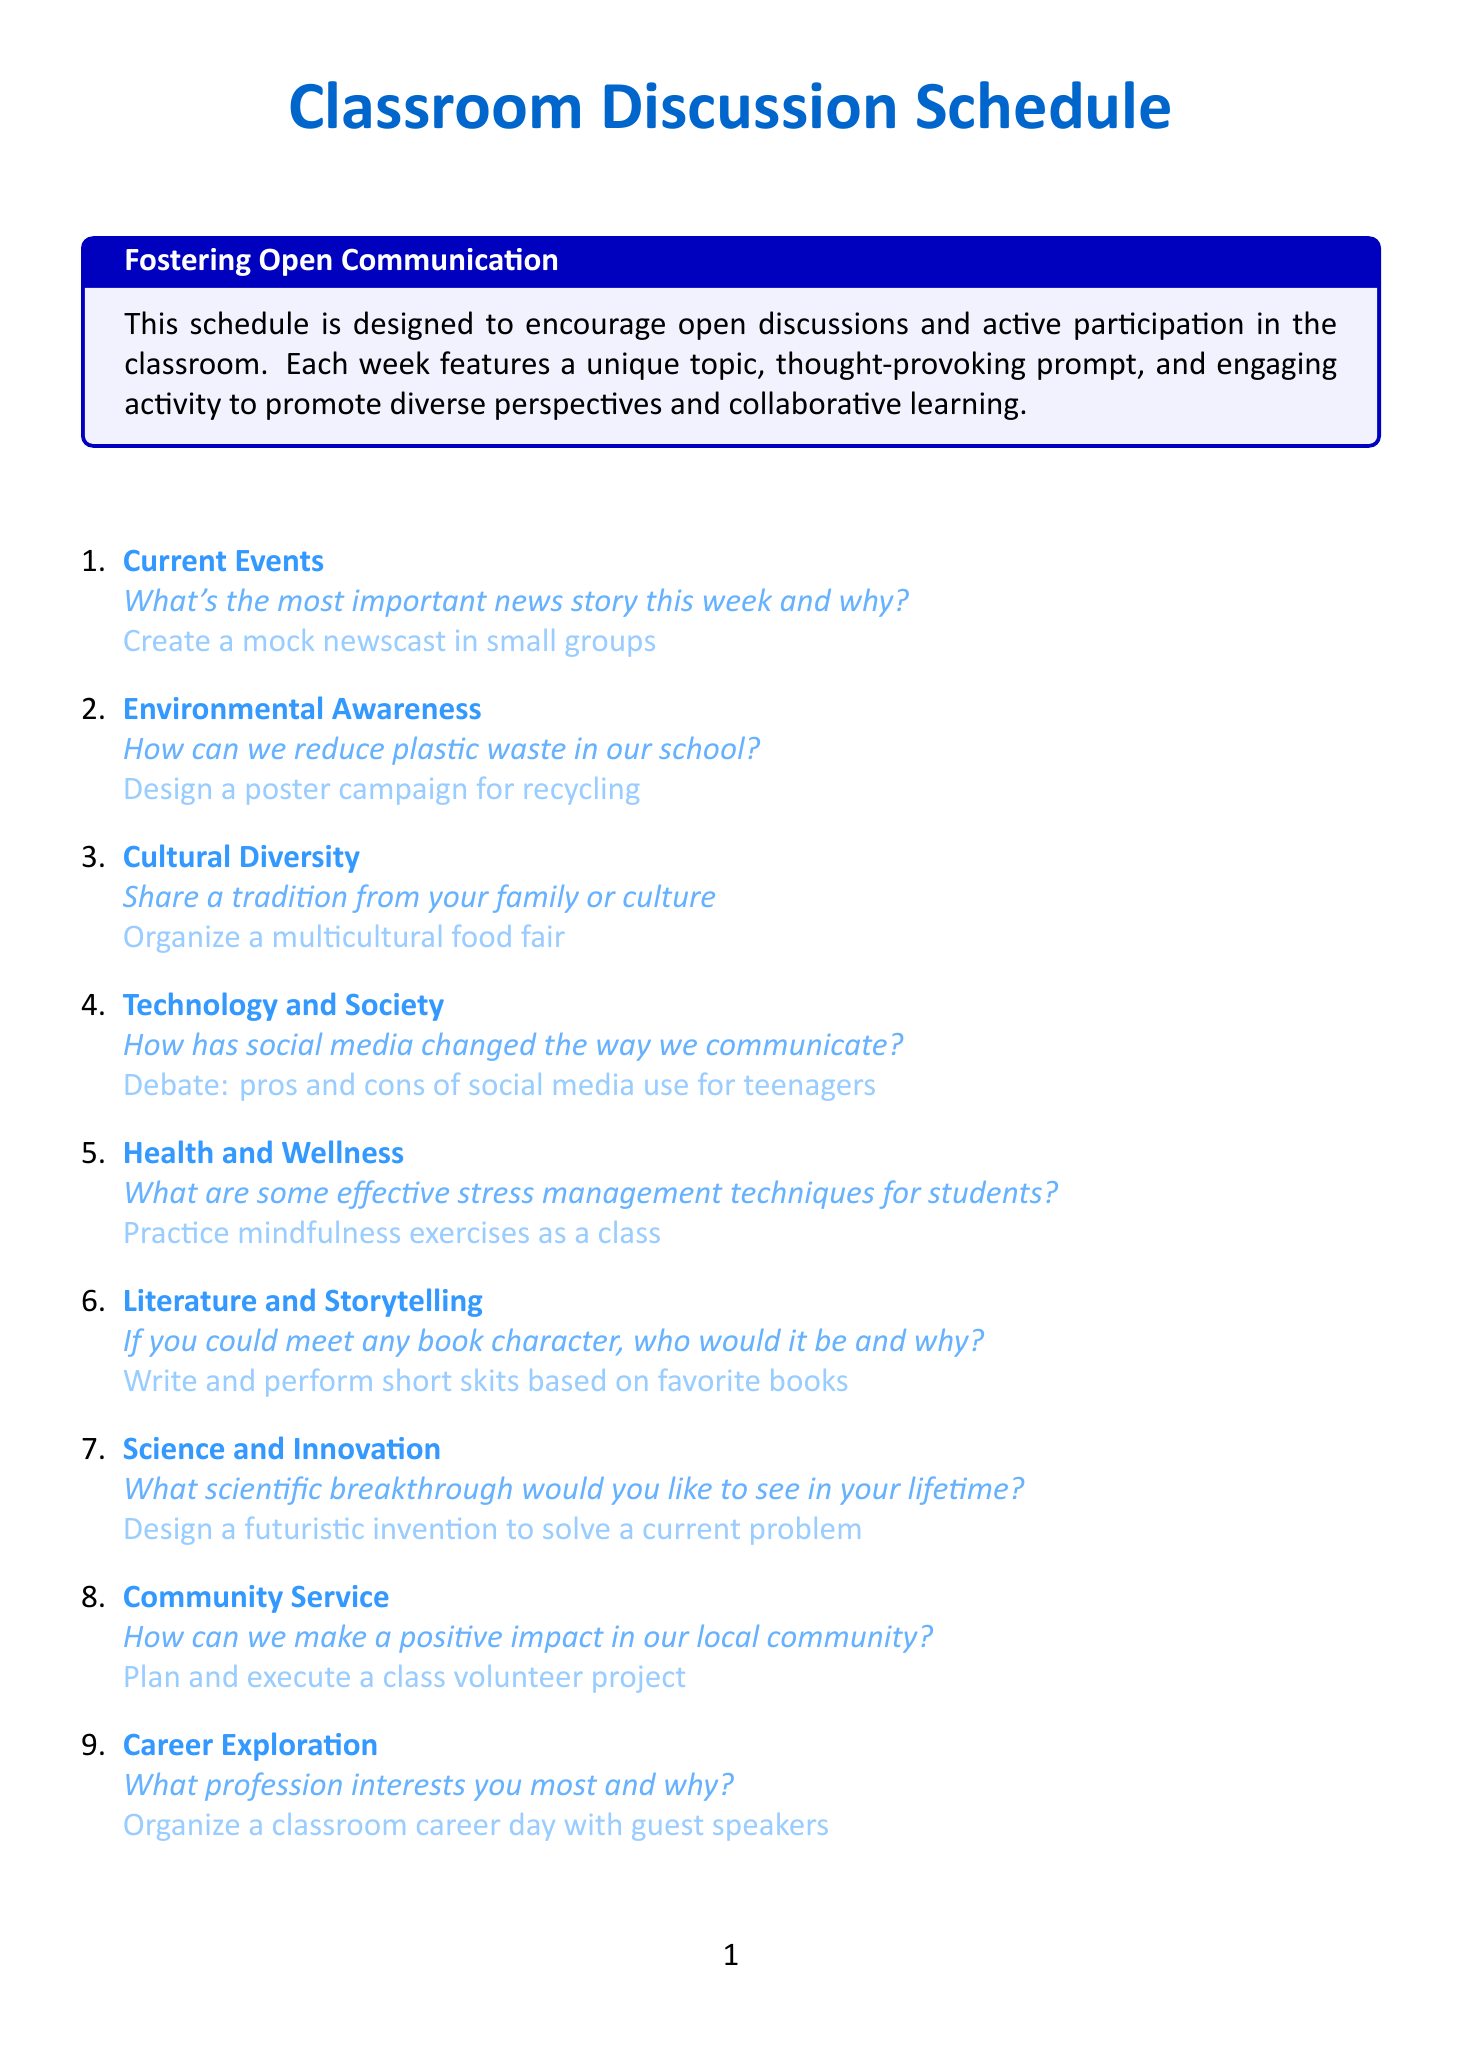What is the topic for week 3? The document lists the topic for week 3 as "Cultural Diversity."
Answer: Cultural Diversity What activity is suggested for week 5? The activity for week 5 is to "Practice mindfulness exercises as a class."
Answer: Practice mindfulness exercises as a class Which week focuses on Technology and Society? The document states that Technology and Society is the focus for week 4.
Answer: week 4 What prompt is given for the discussion in week 10? The prompt for week 10 asks, "How does art reflect society?"
Answer: How does art reflect society? How many discussion topics are listed in total? The document has a total of 12 discussion topics outlined.
Answer: 12 What is the activity planned for week 9? The activity for week 9 is to "Organize a classroom career day with guest speakers."
Answer: Organize a classroom career day with guest speakers What is the prompt for week 6? The prompt for week 6 asks, "If you could meet any book character, who would it be and why?"
Answer: If you could meet any book character, who would it be and why? What topic is discussed in week 11? The document indicates that the topic for week 11 is "Global Issues."
Answer: Global Issues 